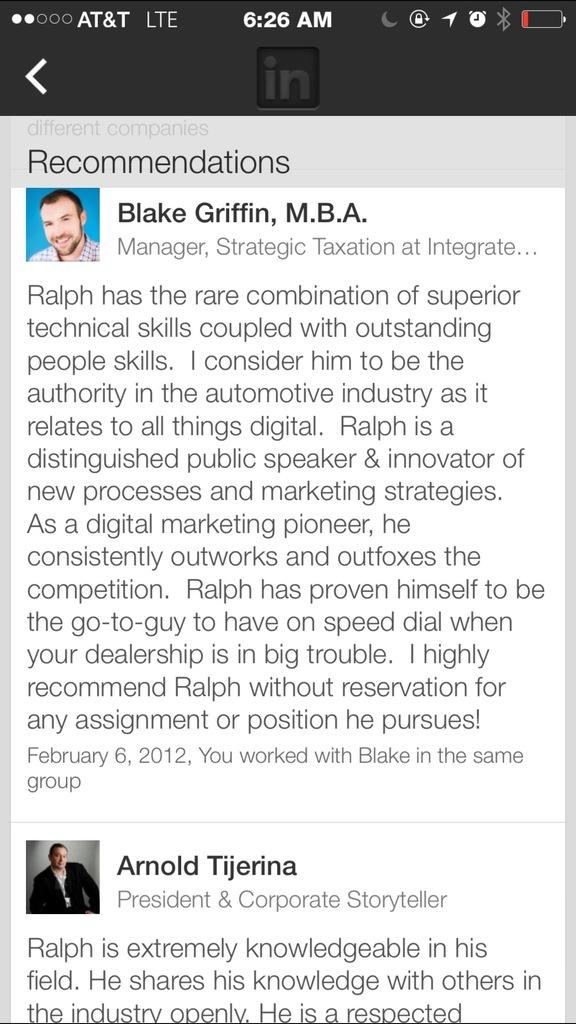What type of device is shown in the image? The image is a screenshot of a mobile device. Can you describe the content of the screenshot? There are two faces visible in the screenshot. What else can be seen on the screen besides the faces? There is text or content visible on the screen. What type of vacation is the person in the image planning? There is no information about a vacation in the image; it only shows two faces and text or content on the screen. 